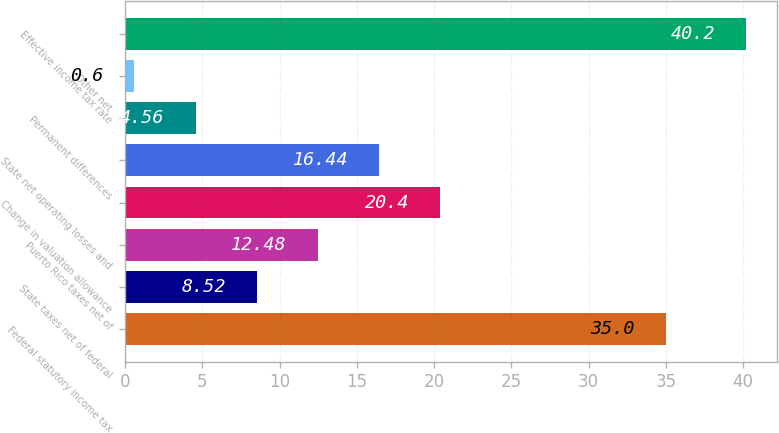Convert chart to OTSL. <chart><loc_0><loc_0><loc_500><loc_500><bar_chart><fcel>Federal statutory income tax<fcel>State taxes net of federal<fcel>Puerto Rico taxes net of<fcel>Change in valuation allowance<fcel>State net operating losses and<fcel>Permanent differences<fcel>Other net<fcel>Effective income tax rate<nl><fcel>35<fcel>8.52<fcel>12.48<fcel>20.4<fcel>16.44<fcel>4.56<fcel>0.6<fcel>40.2<nl></chart> 